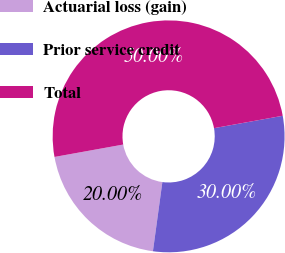<chart> <loc_0><loc_0><loc_500><loc_500><pie_chart><fcel>Actuarial loss (gain)<fcel>Prior service credit<fcel>Total<nl><fcel>20.0%<fcel>30.0%<fcel>50.0%<nl></chart> 